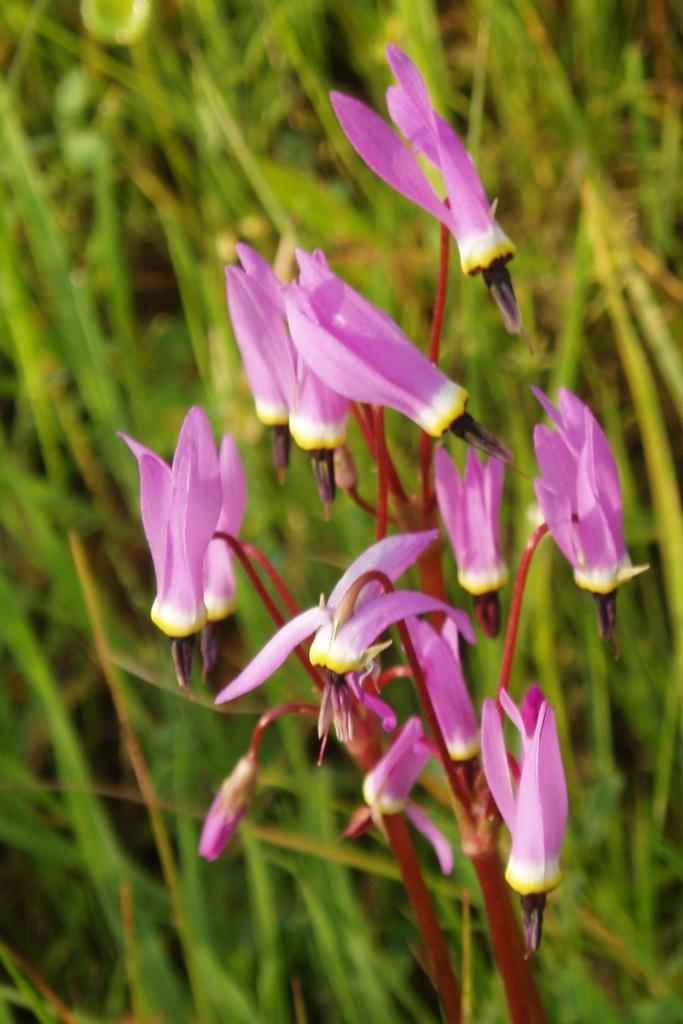What is present in the image? There is a plant in the image. What can be observed about the plant's flowers? The plant has pink color flowers. What type of payment is required to water the plant in the image? There is no mention of payment or watering the plant in the image. 